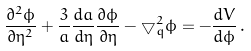<formula> <loc_0><loc_0><loc_500><loc_500>\frac { \partial ^ { 2 } \phi } { \partial \eta ^ { 2 } } + \frac { 3 } { a } \frac { d a } { d \eta } \frac { \partial \phi } { \partial \eta } - \bigtriangledown _ { q } ^ { 2 } \phi = - \frac { d V } { d \phi } \, .</formula> 